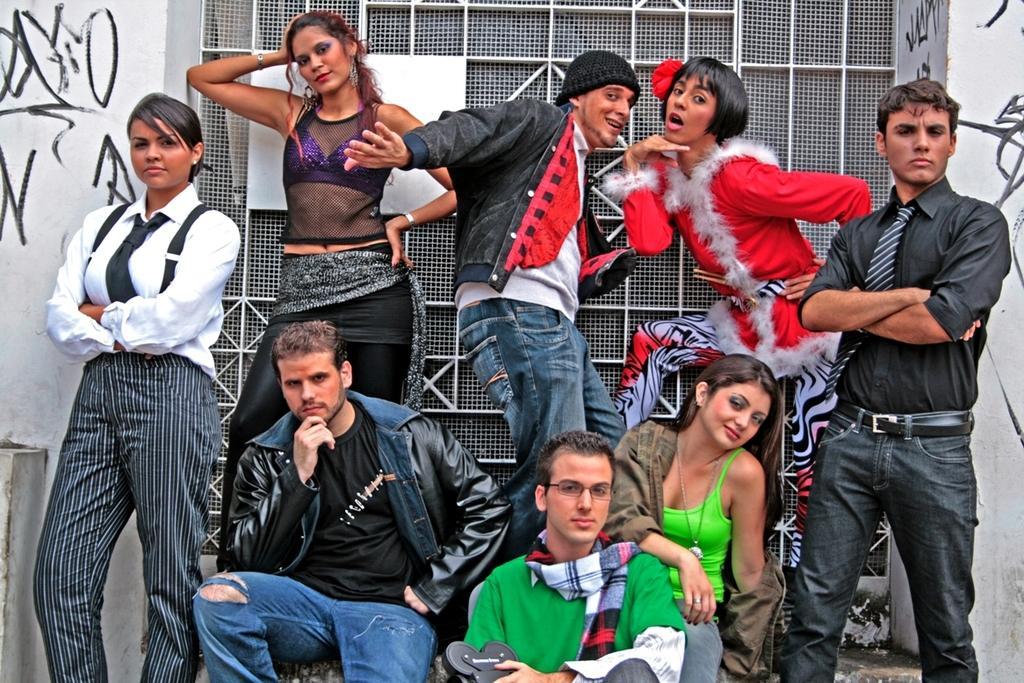Can you describe this image briefly? In this image I can see a group of people wearing different color dresses. Back I can see a white wall and net window. 